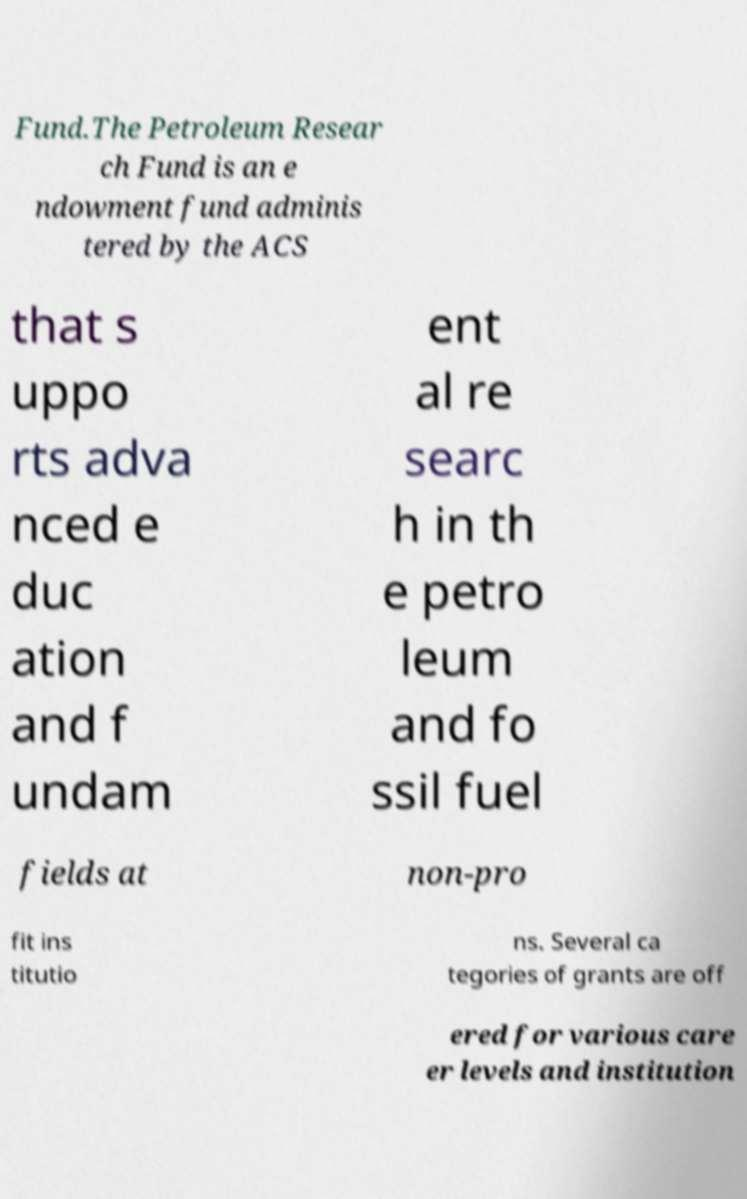There's text embedded in this image that I need extracted. Can you transcribe it verbatim? Fund.The Petroleum Resear ch Fund is an e ndowment fund adminis tered by the ACS that s uppo rts adva nced e duc ation and f undam ent al re searc h in th e petro leum and fo ssil fuel fields at non-pro fit ins titutio ns. Several ca tegories of grants are off ered for various care er levels and institution 